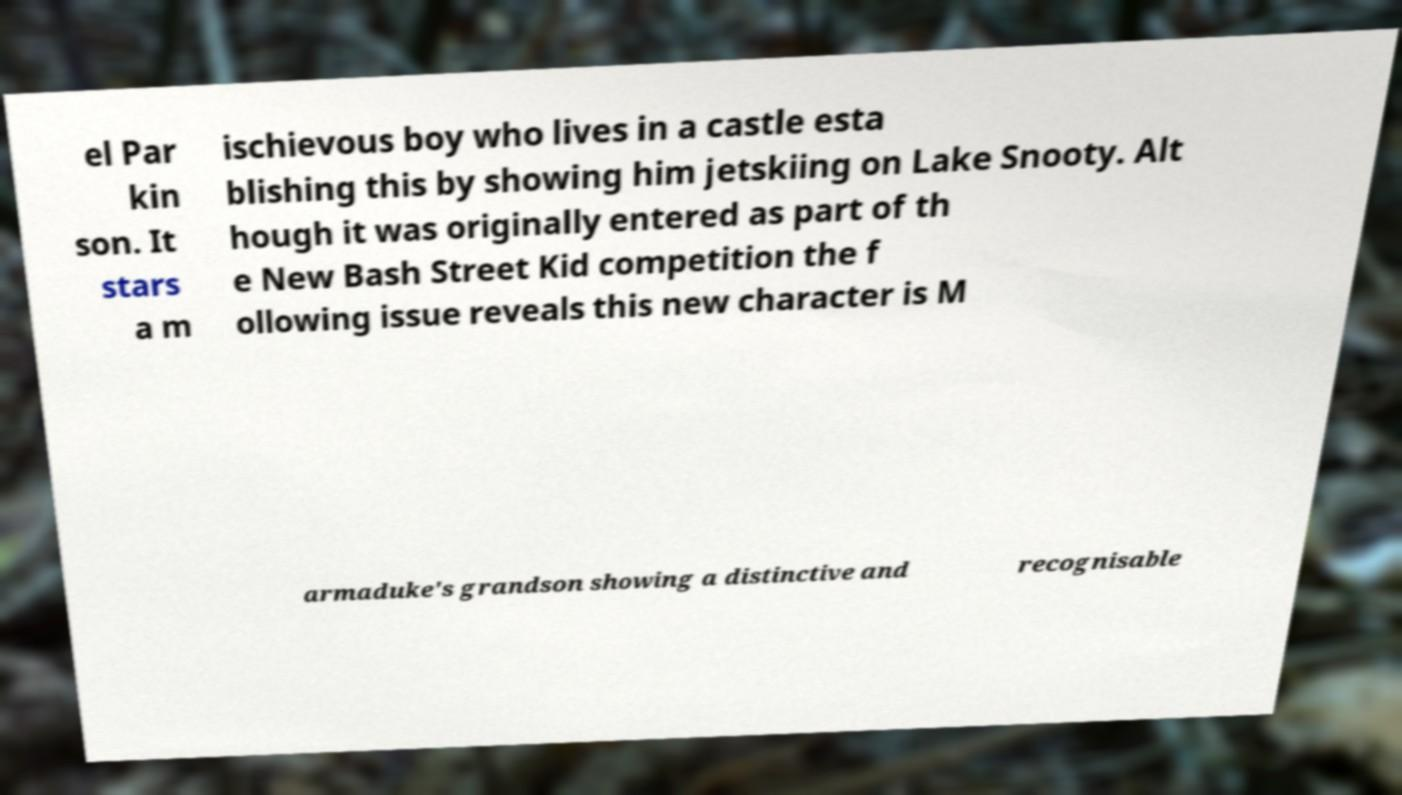I need the written content from this picture converted into text. Can you do that? el Par kin son. It stars a m ischievous boy who lives in a castle esta blishing this by showing him jetskiing on Lake Snooty. Alt hough it was originally entered as part of th e New Bash Street Kid competition the f ollowing issue reveals this new character is M armaduke's grandson showing a distinctive and recognisable 